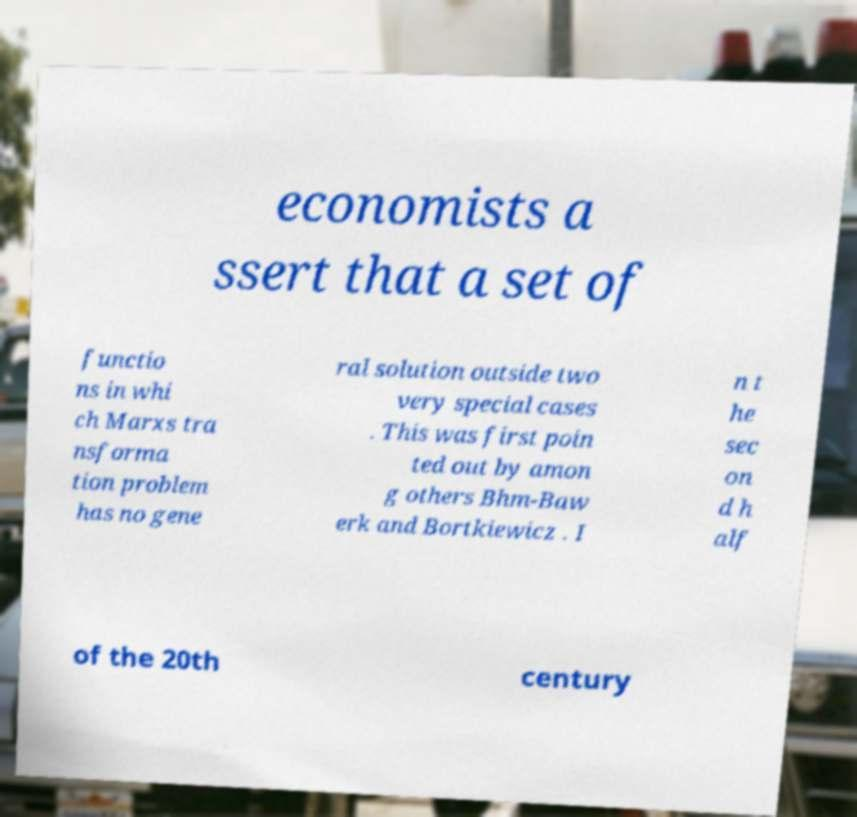Could you extract and type out the text from this image? economists a ssert that a set of functio ns in whi ch Marxs tra nsforma tion problem has no gene ral solution outside two very special cases . This was first poin ted out by amon g others Bhm-Baw erk and Bortkiewicz . I n t he sec on d h alf of the 20th century 